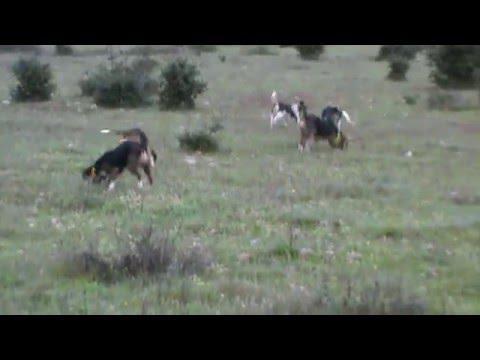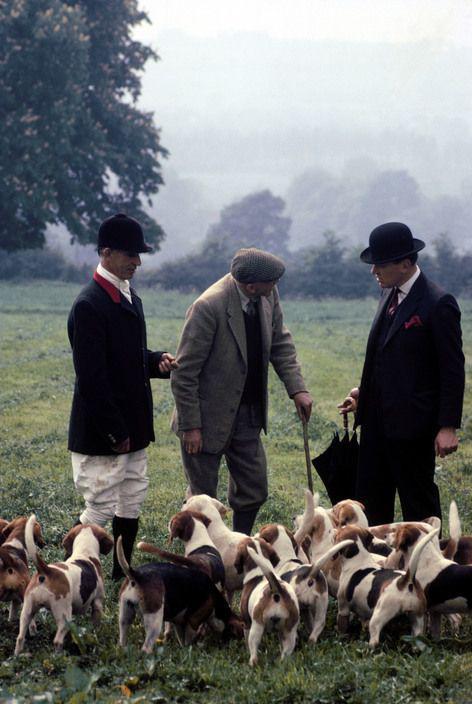The first image is the image on the left, the second image is the image on the right. Given the left and right images, does the statement "Some of the dogs are compacted in a group that are all facing to the immediate left." hold true? Answer yes or no. No. The first image is the image on the left, the second image is the image on the right. Considering the images on both sides, is "In at least one image the beagles are near adult humans." valid? Answer yes or no. Yes. 